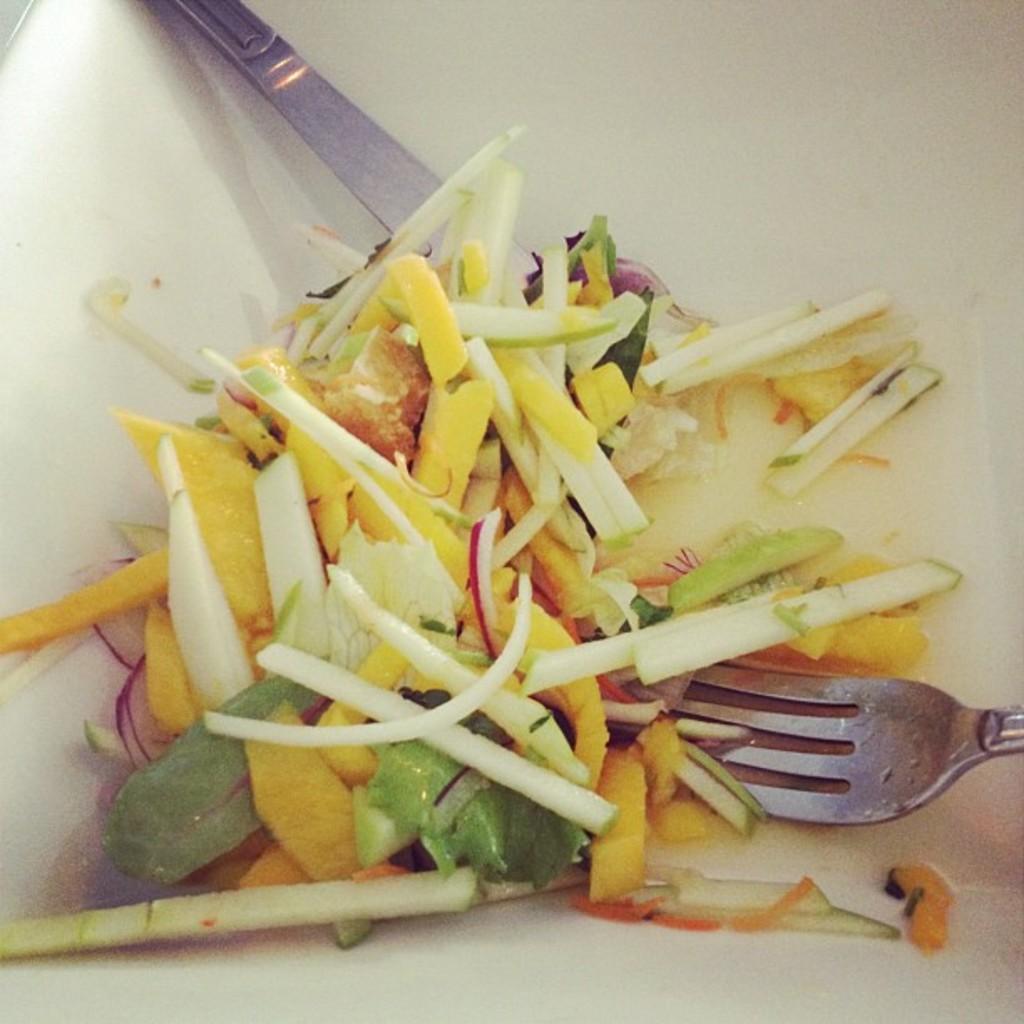Can you describe this image briefly? We can see food in a container, fork and spoon. 